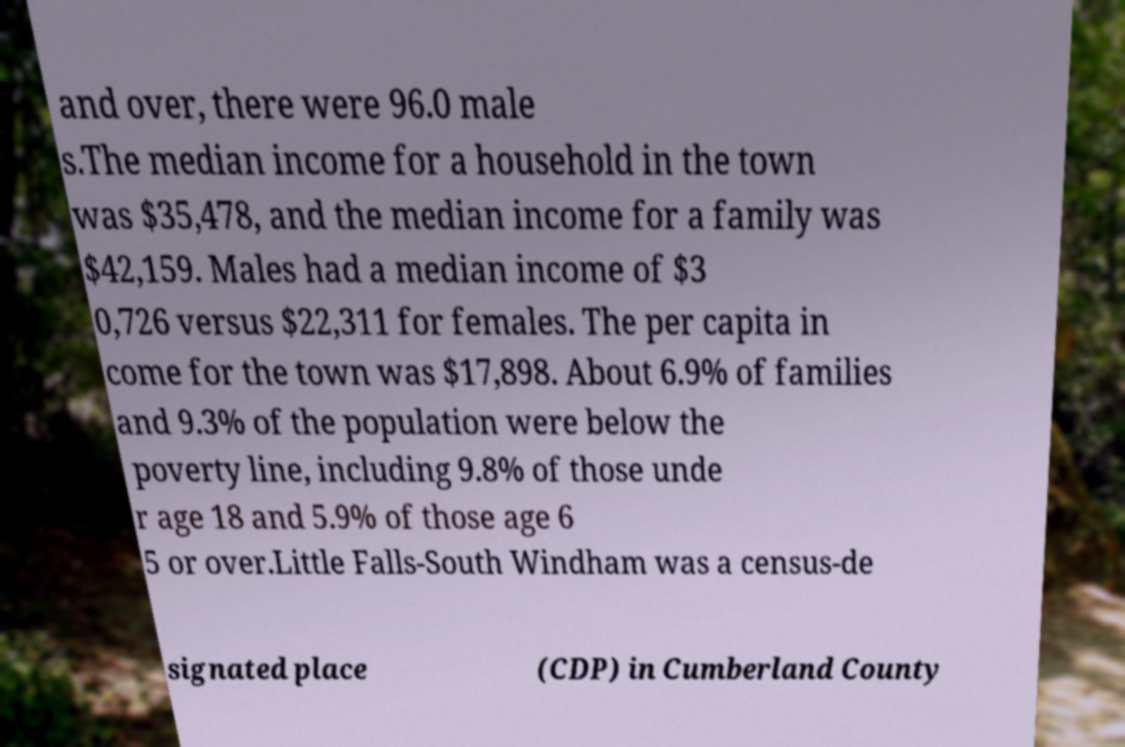There's text embedded in this image that I need extracted. Can you transcribe it verbatim? and over, there were 96.0 male s.The median income for a household in the town was $35,478, and the median income for a family was $42,159. Males had a median income of $3 0,726 versus $22,311 for females. The per capita in come for the town was $17,898. About 6.9% of families and 9.3% of the population were below the poverty line, including 9.8% of those unde r age 18 and 5.9% of those age 6 5 or over.Little Falls-South Windham was a census-de signated place (CDP) in Cumberland County 